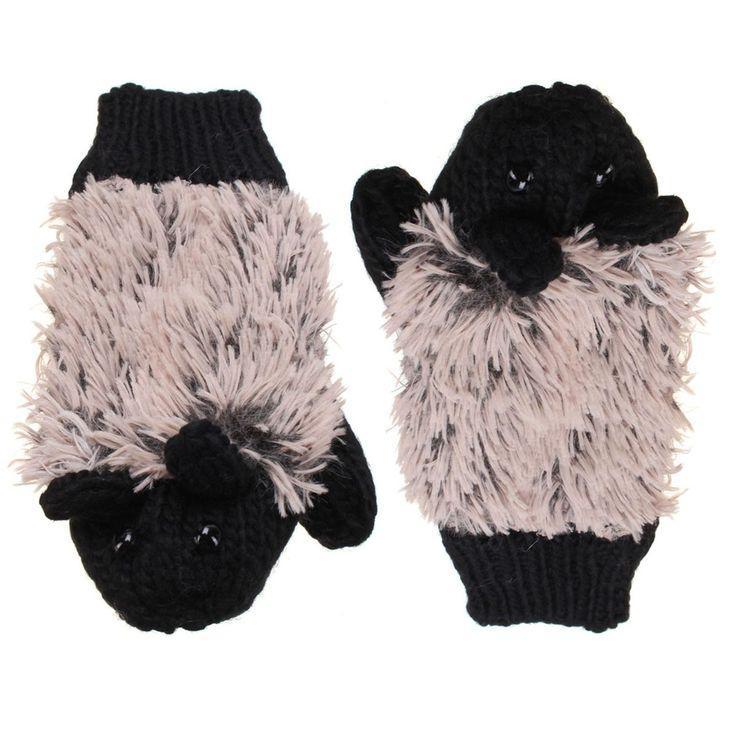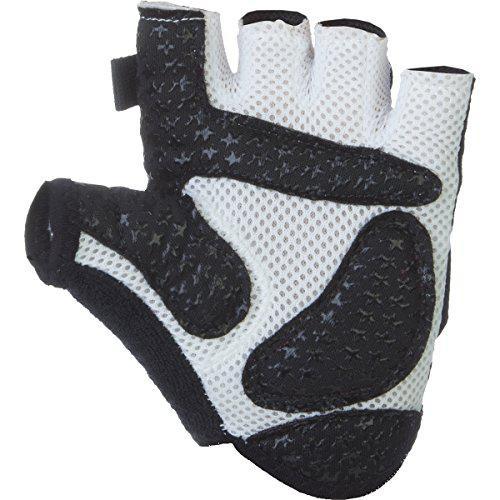The first image is the image on the left, the second image is the image on the right. Given the left and right images, does the statement "Mittens are decorated with fur/faux fur and contain colors other than black." hold true? Answer yes or no. Yes. The first image is the image on the left, the second image is the image on the right. Considering the images on both sides, is "One pair of gloves are knit." valid? Answer yes or no. Yes. 